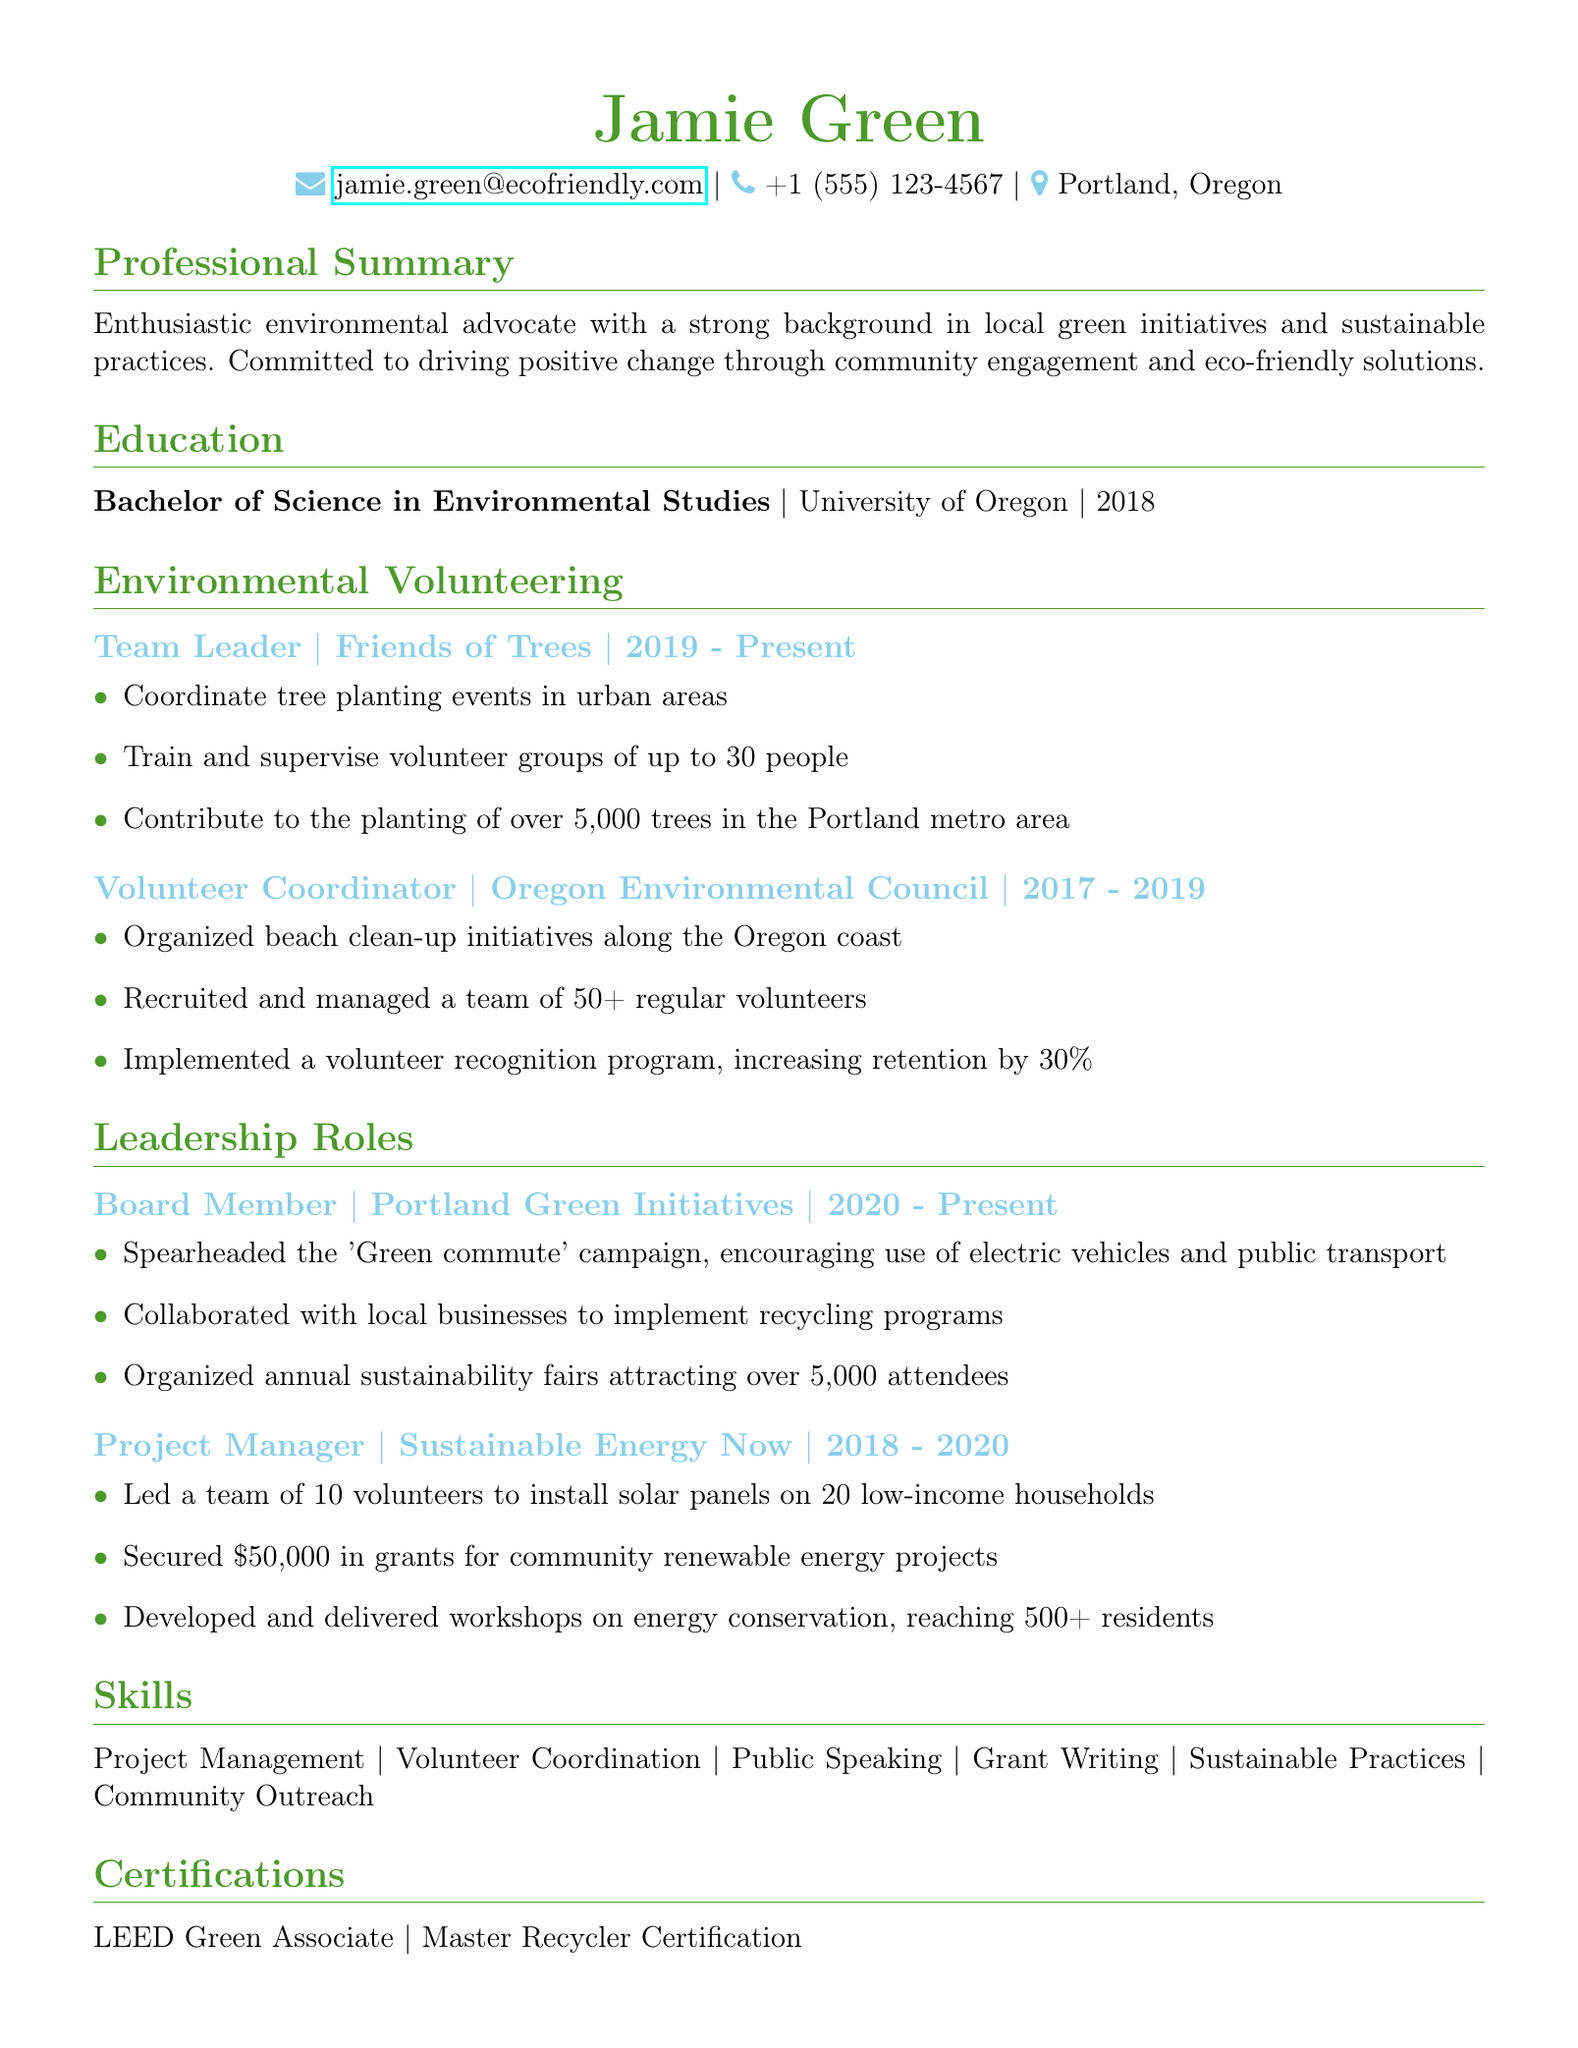What is Jamie Green’s email address? The email address is listed in the personal information section.
Answer: jamie.green@ecofriendly.com What degree did Jamie Green earn? The degree is mentioned under the education section.
Answer: Bachelor of Science in Environmental Studies How many trees has Jamie contributed to planting? This number is noted in the responsibilities for the Friends of Trees role.
Answer: over 5,000 trees What role did Jamie have with the Oregon Environmental Council? The role is specified in the environmental volunteering section.
Answer: Volunteer Coordinator What campaign did Jamie spearhead as a Board Member? The campaign's name is listed under leadership roles at Portland Green Initiatives.
Answer: Green commute How many volunteers did Jamie manage at the Oregon Environmental Council? This information can be found in the responsibilities for the Volunteer Coordinator role.
Answer: 50+ regular volunteers Which certification does Jamie hold? The certifications section lists the qualifications.
Answer: LEED Green Associate In which year did Jamie graduate? The graduation year is stated in the education section.
Answer: 2018 How many attendees were attracted by the annual sustainability fairs organized by Jamie? This number is mentioned in the achievements of the Board Member role.
Answer: over 5,000 attendees 